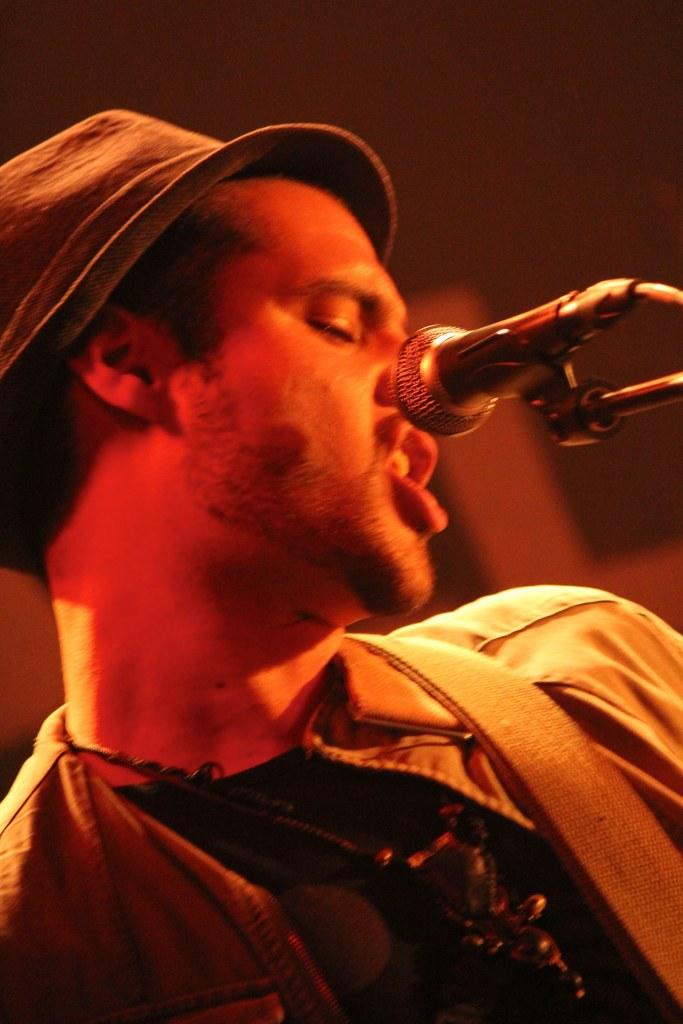Who is present in the image? There is a man in the image. What is the man wearing on his head? The man is wearing a hat. What object can be seen in the image that is typically used for amplifying sound? There is a microphone in the image. Can you describe the background of the image? The background of the image appears blurred. What type of powder is being used by the man in the image? There is no powder visible in the image. What direction is the man facing in the image? The image does not provide enough information to determine the direction the man is facing. 